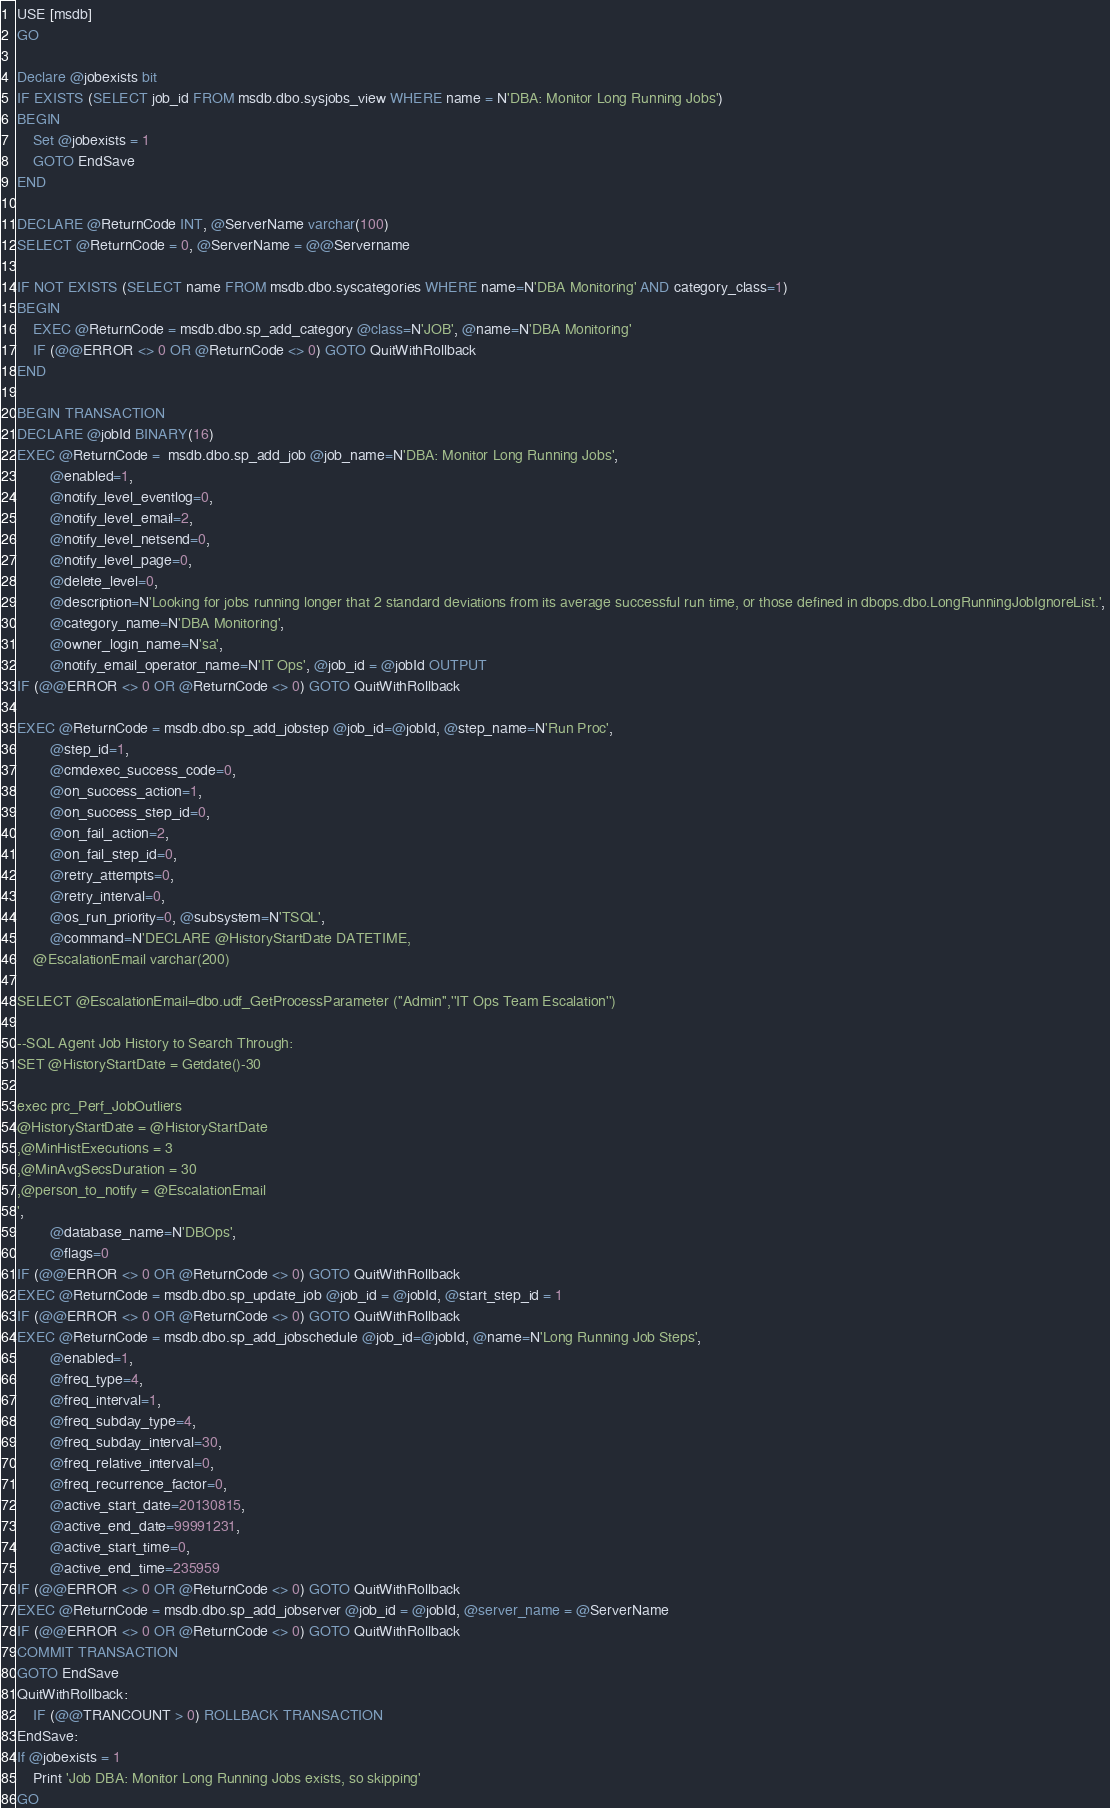<code> <loc_0><loc_0><loc_500><loc_500><_SQL_>USE [msdb]
GO

Declare @jobexists bit
IF EXISTS (SELECT job_id FROM msdb.dbo.sysjobs_view WHERE name = N'DBA: Monitor Long Running Jobs')
BEGIN
	Set @jobexists = 1
	GOTO EndSave
END

DECLARE @ReturnCode INT, @ServerName varchar(100)
SELECT @ReturnCode = 0, @ServerName = @@Servername

IF NOT EXISTS (SELECT name FROM msdb.dbo.syscategories WHERE name=N'DBA Monitoring' AND category_class=1)
BEGIN
	EXEC @ReturnCode = msdb.dbo.sp_add_category @class=N'JOB', @name=N'DBA Monitoring'
	IF (@@ERROR <> 0 OR @ReturnCode <> 0) GOTO QuitWithRollback
END

BEGIN TRANSACTION
DECLARE @jobId BINARY(16)
EXEC @ReturnCode =  msdb.dbo.sp_add_job @job_name=N'DBA: Monitor Long Running Jobs', 
		@enabled=1, 
		@notify_level_eventlog=0, 
		@notify_level_email=2, 
		@notify_level_netsend=0, 
		@notify_level_page=0, 
		@delete_level=0, 
		@description=N'Looking for jobs running longer that 2 standard deviations from its average successful run time, or those defined in dbops.dbo.LongRunningJobIgnoreList.', 
		@category_name=N'DBA Monitoring', 
		@owner_login_name=N'sa', 
		@notify_email_operator_name=N'IT Ops', @job_id = @jobId OUTPUT
IF (@@ERROR <> 0 OR @ReturnCode <> 0) GOTO QuitWithRollback

EXEC @ReturnCode = msdb.dbo.sp_add_jobstep @job_id=@jobId, @step_name=N'Run Proc', 
		@step_id=1, 
		@cmdexec_success_code=0, 
		@on_success_action=1, 
		@on_success_step_id=0, 
		@on_fail_action=2, 
		@on_fail_step_id=0, 
		@retry_attempts=0, 
		@retry_interval=0, 
		@os_run_priority=0, @subsystem=N'TSQL', 
		@command=N'DECLARE @HistoryStartDate DATETIME,
	@EscalationEmail varchar(200)

SELECT @EscalationEmail=dbo.udf_GetProcessParameter (''Admin'',''IT Ops Team Escalation'')

--SQL Agent Job History to Search Through:
SET @HistoryStartDate = Getdate()-30

exec prc_Perf_JobOutliers
@HistoryStartDate = @HistoryStartDate 
,@MinHistExecutions = 3
,@MinAvgSecsDuration = 30
,@person_to_notify = @EscalationEmail
', 
		@database_name=N'DBOps', 
		@flags=0
IF (@@ERROR <> 0 OR @ReturnCode <> 0) GOTO QuitWithRollback
EXEC @ReturnCode = msdb.dbo.sp_update_job @job_id = @jobId, @start_step_id = 1
IF (@@ERROR <> 0 OR @ReturnCode <> 0) GOTO QuitWithRollback
EXEC @ReturnCode = msdb.dbo.sp_add_jobschedule @job_id=@jobId, @name=N'Long Running Job Steps', 
		@enabled=1, 
		@freq_type=4, 
		@freq_interval=1, 
		@freq_subday_type=4, 
		@freq_subday_interval=30, 
		@freq_relative_interval=0, 
		@freq_recurrence_factor=0, 
		@active_start_date=20130815, 
		@active_end_date=99991231, 
		@active_start_time=0, 
		@active_end_time=235959
IF (@@ERROR <> 0 OR @ReturnCode <> 0) GOTO QuitWithRollback
EXEC @ReturnCode = msdb.dbo.sp_add_jobserver @job_id = @jobId, @server_name = @ServerName
IF (@@ERROR <> 0 OR @ReturnCode <> 0) GOTO QuitWithRollback
COMMIT TRANSACTION
GOTO EndSave
QuitWithRollback:
    IF (@@TRANCOUNT > 0) ROLLBACK TRANSACTION
EndSave:
If @jobexists = 1
	Print 'Job DBA: Monitor Long Running Jobs exists, so skipping' 
GO

</code> 